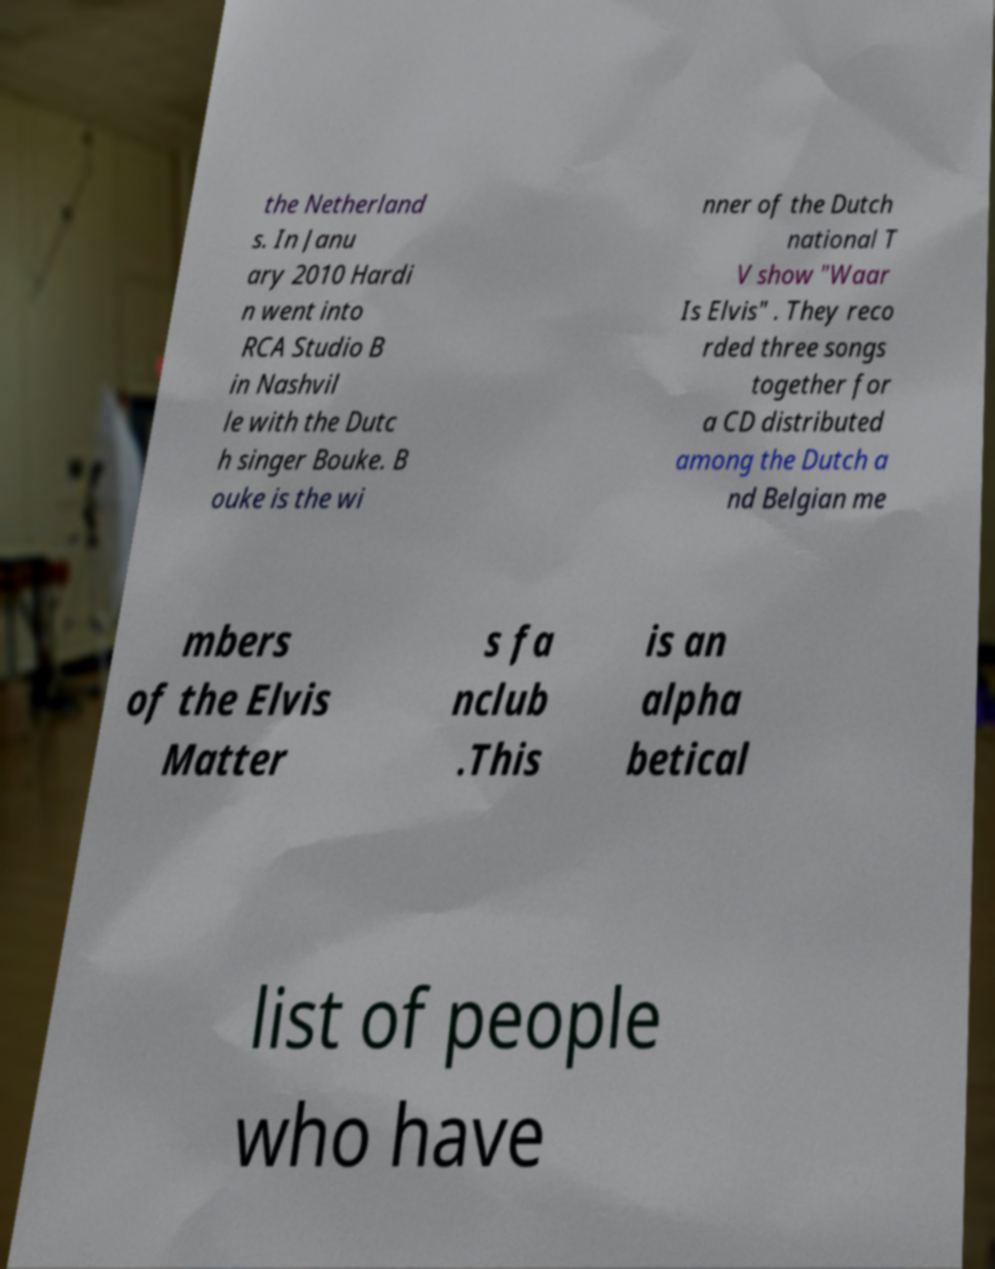There's text embedded in this image that I need extracted. Can you transcribe it verbatim? the Netherland s. In Janu ary 2010 Hardi n went into RCA Studio B in Nashvil le with the Dutc h singer Bouke. B ouke is the wi nner of the Dutch national T V show "Waar Is Elvis" . They reco rded three songs together for a CD distributed among the Dutch a nd Belgian me mbers of the Elvis Matter s fa nclub .This is an alpha betical list of people who have 